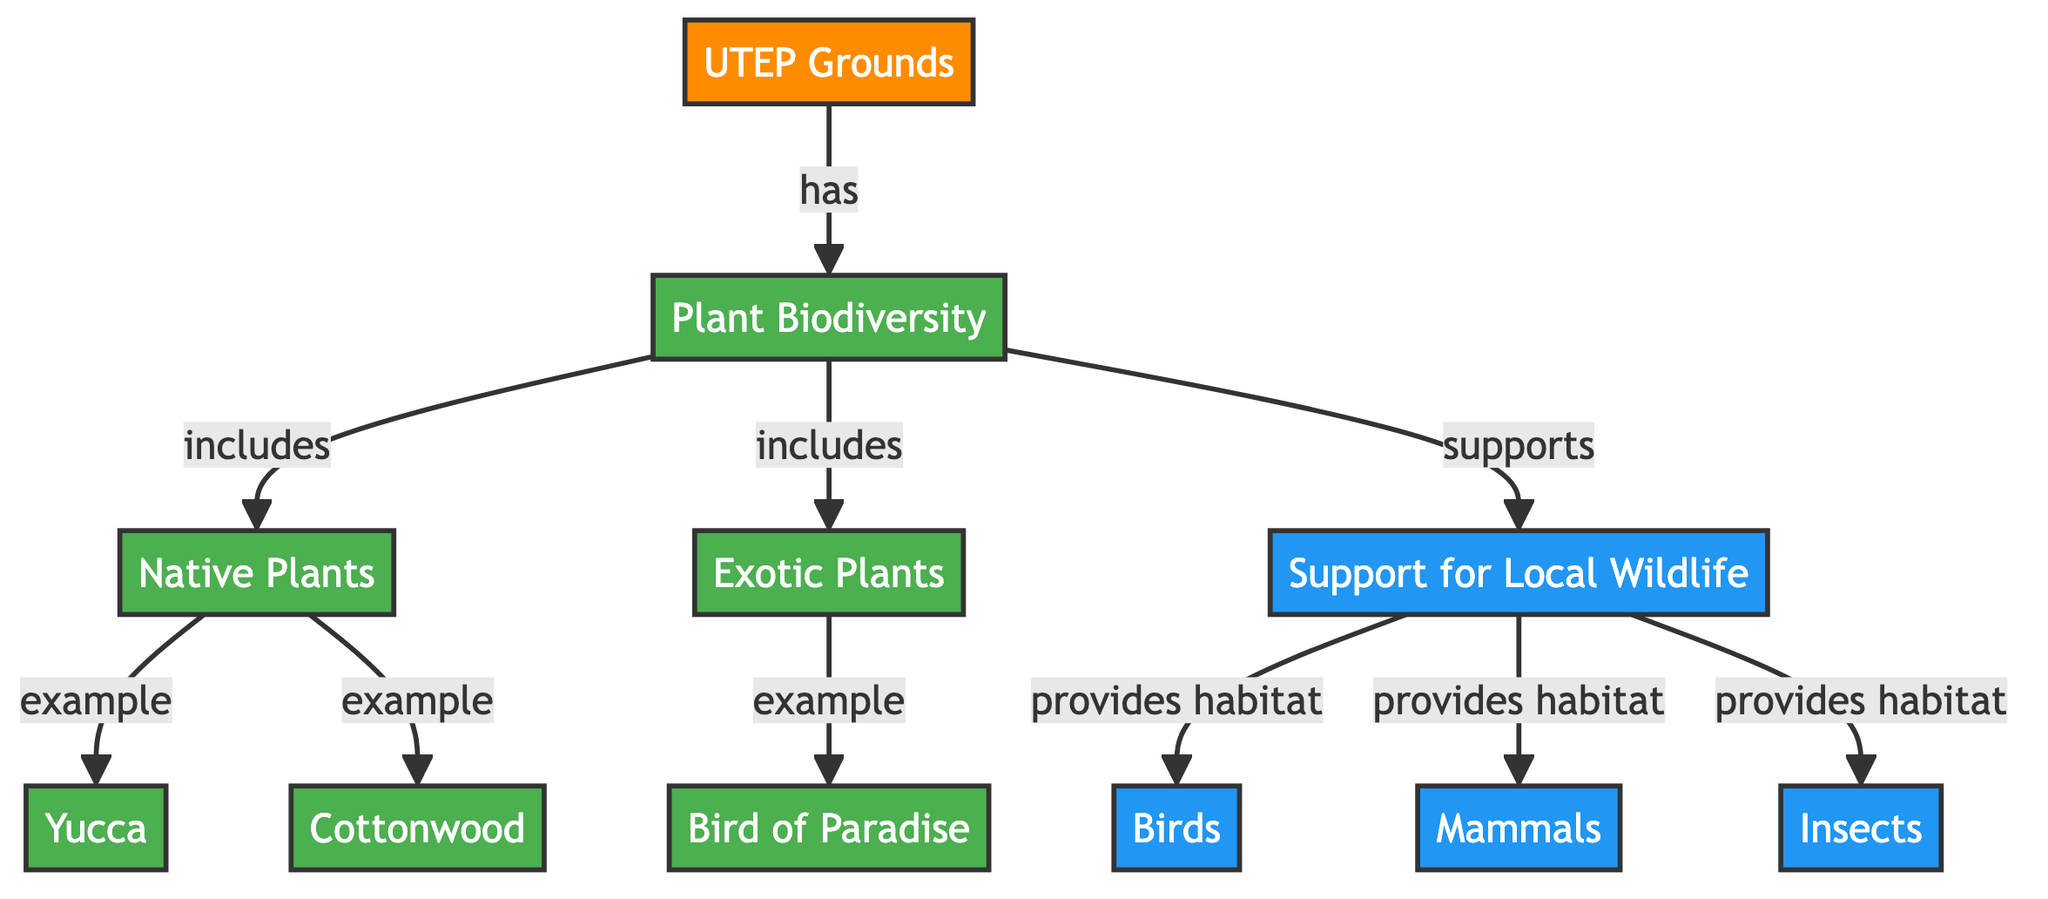What does UTEP have? The diagram indicates that UTEP has Plant Biodiversity, clearly labeled as a relationship from UTEP to Plant Biodiversity. Thus, the answer directly reflects the content in the diagram.
Answer: Plant Biodiversity How many types of plants are included in plant biodiversity? The diagram shows two categories under Plant Biodiversity, namely Native Plants and Exotic Plants. By counting these, we find there are exactly two types.
Answer: 2 Which example of native plant is mentioned? The diagram lists examples of Native Plants, with Yucca being one of them. This is indicated in the flow from Native Plants to the specific example.
Answer: Yucca What is one example of an exotic plant? The diagram explicitly provides an example of an Exotic Plant, which is Bird of Paradise. It is shown as a subset under Exotic Plants.
Answer: Bird of Paradise What does the Plant Biodiversity support? According to the diagram, Plant Biodiversity supports Local Wildlife, which is a direct relation illustrated in the flow chart. This indicates that biodiversity is beneficial for wildlife.
Answer: Local Wildlife Which type of wildlife does the diagram mention that is provided habitat? There are three types of wildlife mentioned, namely Birds, Mammals, and Insects. Each is directly linked to the support provided by Plant Biodiversity. Thus, any of these is an acceptable answer.
Answer: Birds What role does plant biodiversity play in the ecosystem according to the diagram? The diagram highlights Plant Biodiversity's role in supporting Local Wildlife, suggesting it provides necessary habitats. This connects the plants directly with the wildlife support role, demonstrating their importance in the ecosystem.
Answer: Supports Local Wildlife How many specific wildlife categories are supported by plant biodiversity? The diagram specifies three categories of wildlife supported by plant biodiversity: Birds, Mammals, and Insects. This clear enumeration provides a straightforward numerical answer.
Answer: 3 What is an example of a native plant shown in the diagram? The diagram shows Yucca and Cottonwood as examples under Native Plants, so either can be a correct answer. It states the relationship from Native Plants to its examples.
Answer: Yucca 